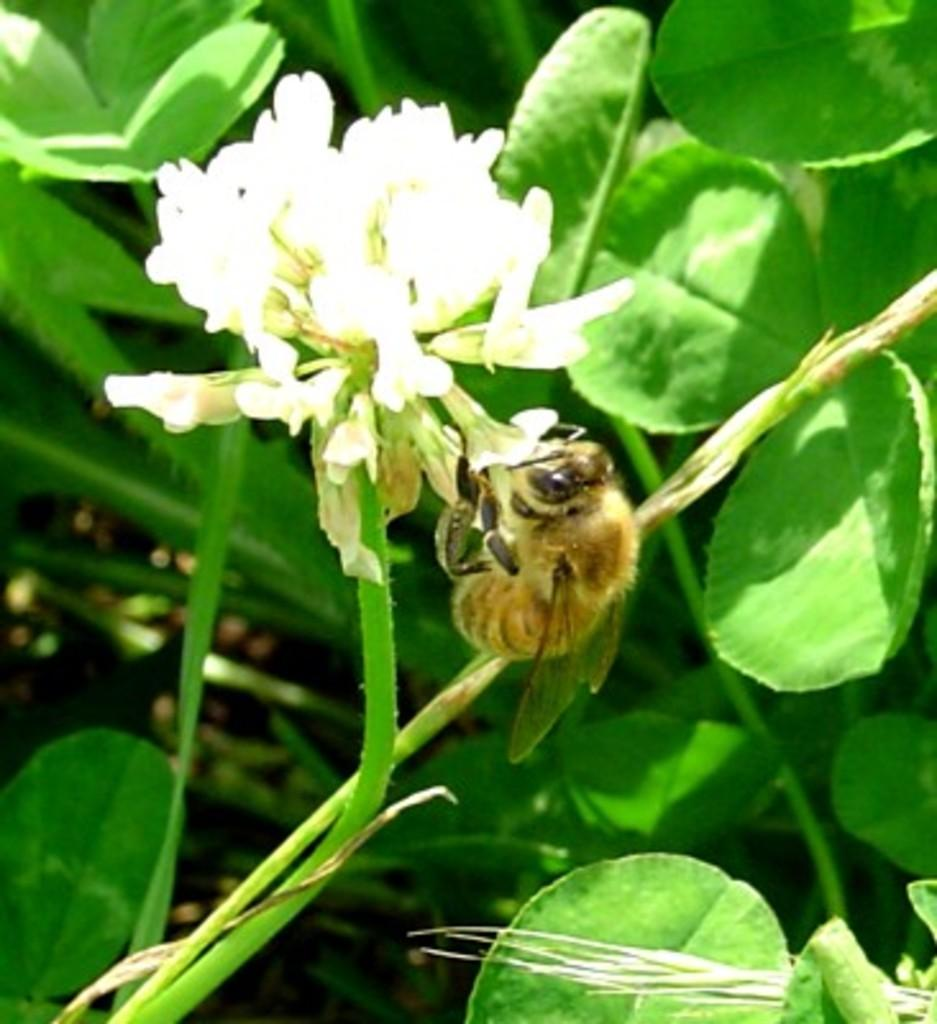What type of insect is present in the image? There is a honeybee in the image. What is the honeybee interacting with in the image? The honeybee is interacting with flowers in the image. What type of vegetation is present in the image? There are plants in the image. How would you describe the background of the image? The background of the image is blurred. Can you tell me how many wings the cellar has in the image? There is no cellar present in the image, and therefore no wings to count. 